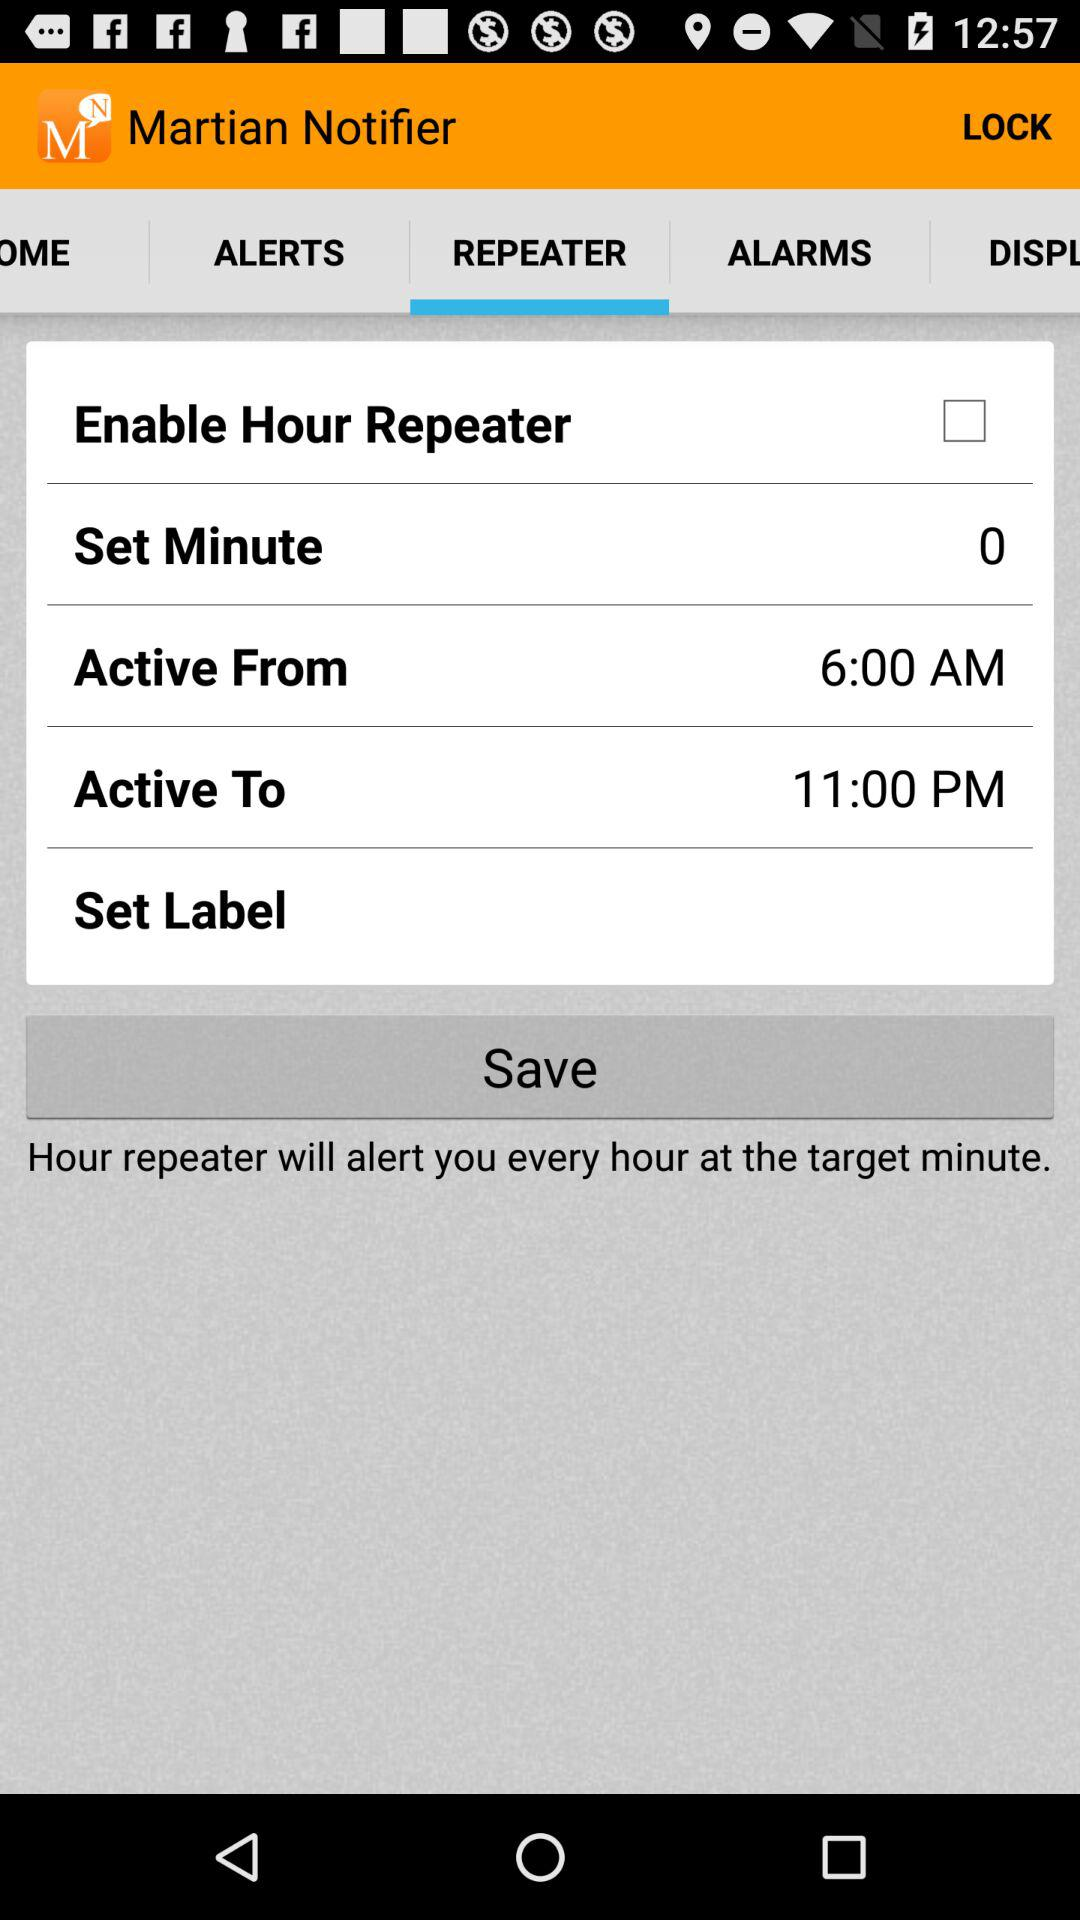At 11:00 PM Which option is set?
When the provided information is insufficient, respond with <no answer>. <no answer> 